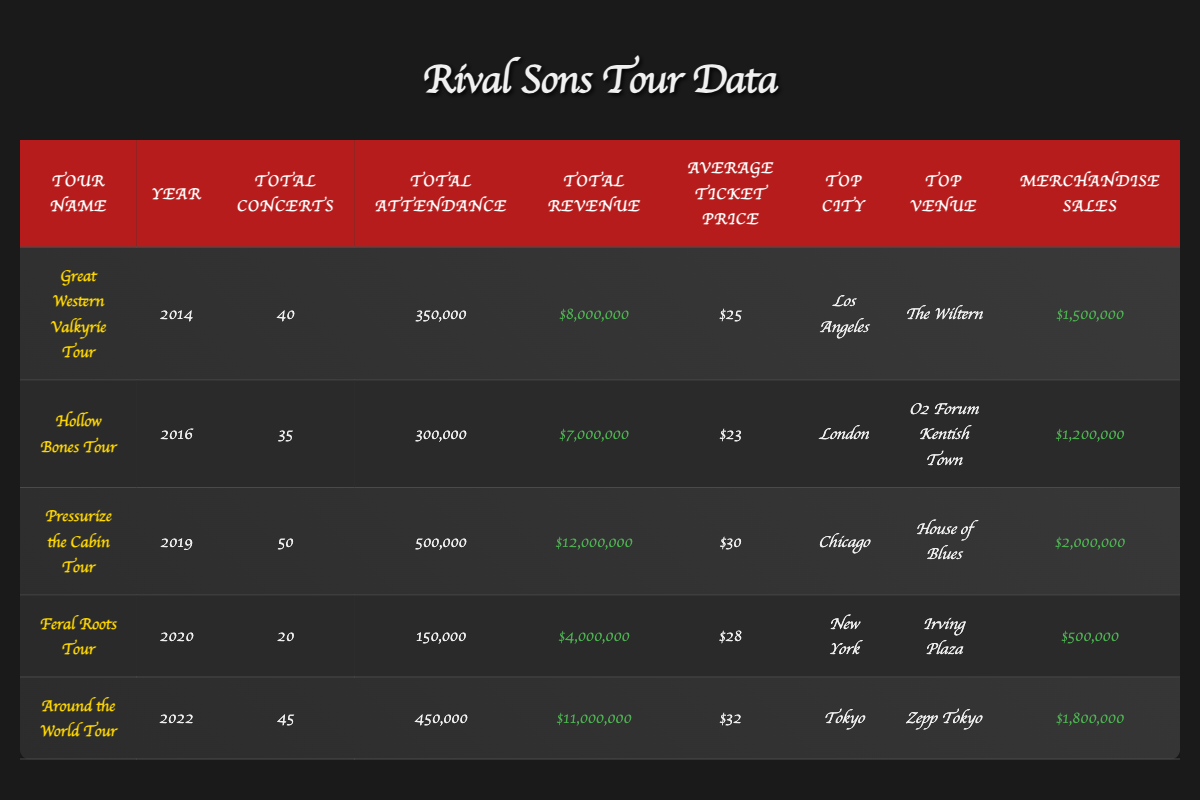What was the total attendance for the "Pressurize the Cabin Tour"? The table provides the total attendance for each tour. For the "Pressurize the Cabin Tour," the attendance is listed as 500,000.
Answer: 500,000 Which tour generated the highest total revenue? By comparing the total revenue figures for each tour in the table, we find that the "Pressurize the Cabin Tour" generated the highest total revenue at $12,000,000.
Answer: "Pressurize the Cabin Tour" How many concerts were performed during the "Great Western Valkyrie Tour"? The total concerts for the "Great Western Valkyrie Tour" are provided in the table, which shows that there were 40 concerts performed.
Answer: 40 What was the average ticket price during the "Hollow Bones Tour"? The average ticket price is specified in the table for the "Hollow Bones Tour," and it was $23.
Answer: $23 Which city was the top city for the "Feral Roots Tour"? The table lists the top city for each tour, and for the "Feral Roots Tour," the top city is New York.
Answer: New York Calculate the total merchandise sales from the "Around the World Tour" and "Feral Roots Tour". The merchandise sales for both tours are $1,800,000 (Around the World Tour) and $500,000 (Feral Roots Tour). Adding these amounts gives a total of $1,800,000 + $500,000 = $2,300,000.
Answer: $2,300,000 What is the difference in attendance between the "Hollow Bones Tour" and the "Great Western Valkyrie Tour"? The attendance for the "Hollow Bones Tour" is 300,000 and for the "Great Western Valkyrie Tour" it is 350,000. The difference in attendance is 350,000 - 300,000 = 50,000.
Answer: 50,000 Is there a tour in which the average ticket price exceeded $30? The table shows that the average ticket price for "Pressurize the Cabin Tour" ($30) and "Around the World Tour" ($32) exceeds $30, confirming the statement to be true.
Answer: Yes Which tour had the lowest total revenue? By examining the total revenue figures, the "Feral Roots Tour" is noted to have the lowest revenue of $4,000,000 when compared to the others.
Answer: "Feral Roots Tour" How many tours had total attendance greater than 400,000? The tours with total attendance greater than 400,000 are "Pressurize the Cabin Tour" (500,000) and "Around the World Tour" (450,000), so there are 2 tours that meet this criterion.
Answer: 2 